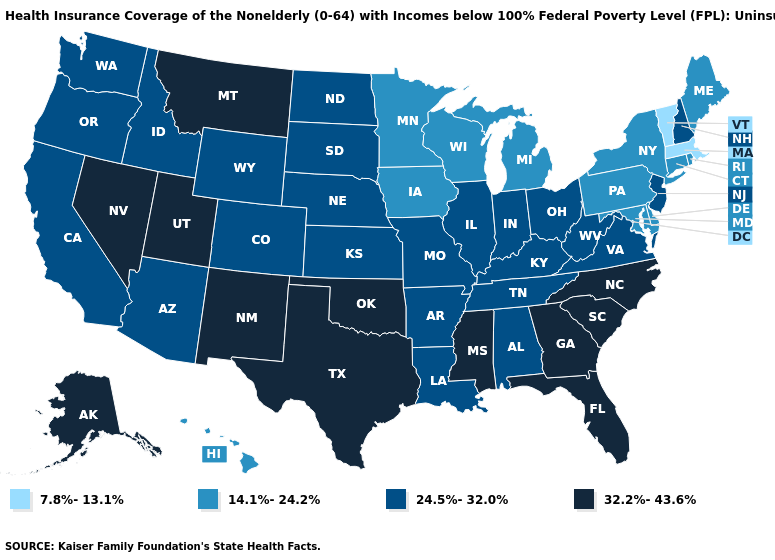What is the value of Vermont?
Short answer required. 7.8%-13.1%. Among the states that border Nebraska , does Iowa have the highest value?
Keep it brief. No. Does California have a higher value than Michigan?
Give a very brief answer. Yes. Name the states that have a value in the range 32.2%-43.6%?
Short answer required. Alaska, Florida, Georgia, Mississippi, Montana, Nevada, New Mexico, North Carolina, Oklahoma, South Carolina, Texas, Utah. What is the highest value in states that border North Dakota?
Quick response, please. 32.2%-43.6%. What is the highest value in states that border Tennessee?
Short answer required. 32.2%-43.6%. Among the states that border Arkansas , does Missouri have the lowest value?
Concise answer only. Yes. What is the highest value in states that border South Carolina?
Write a very short answer. 32.2%-43.6%. Which states have the lowest value in the West?
Quick response, please. Hawaii. What is the highest value in the Northeast ?
Write a very short answer. 24.5%-32.0%. Does Maryland have the lowest value in the South?
Write a very short answer. Yes. Which states have the highest value in the USA?
Give a very brief answer. Alaska, Florida, Georgia, Mississippi, Montana, Nevada, New Mexico, North Carolina, Oklahoma, South Carolina, Texas, Utah. Name the states that have a value in the range 14.1%-24.2%?
Write a very short answer. Connecticut, Delaware, Hawaii, Iowa, Maine, Maryland, Michigan, Minnesota, New York, Pennsylvania, Rhode Island, Wisconsin. Name the states that have a value in the range 32.2%-43.6%?
Give a very brief answer. Alaska, Florida, Georgia, Mississippi, Montana, Nevada, New Mexico, North Carolina, Oklahoma, South Carolina, Texas, Utah. What is the highest value in the Northeast ?
Concise answer only. 24.5%-32.0%. 